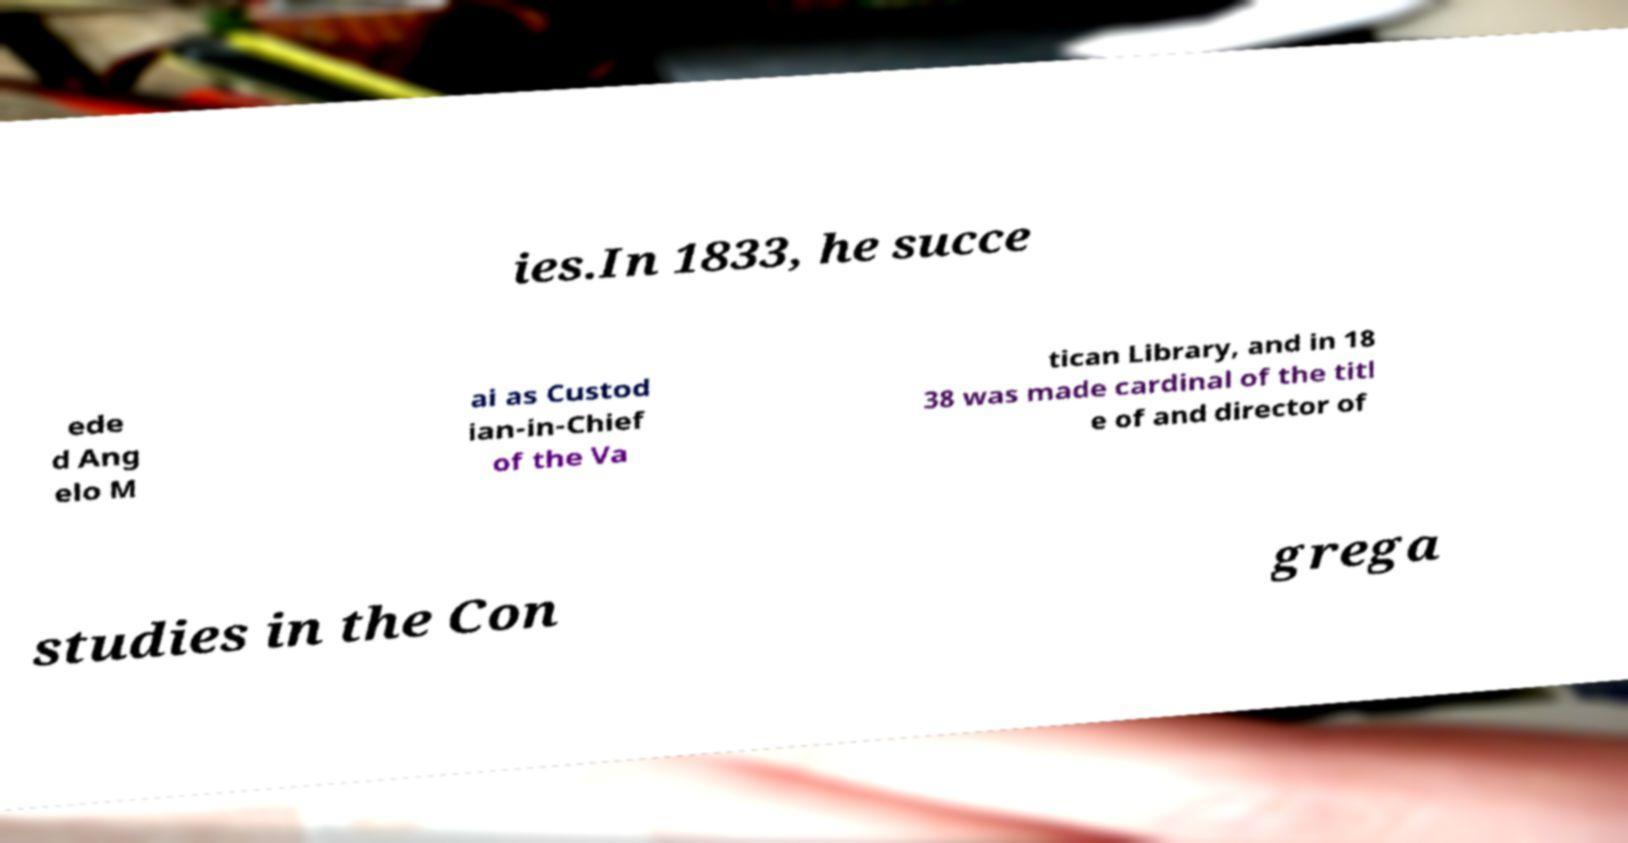Could you assist in decoding the text presented in this image and type it out clearly? ies.In 1833, he succe ede d Ang elo M ai as Custod ian-in-Chief of the Va tican Library, and in 18 38 was made cardinal of the titl e of and director of studies in the Con grega 